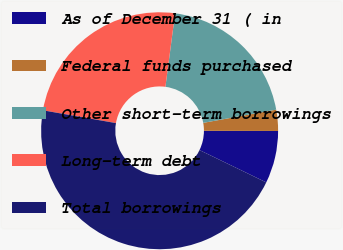Convert chart to OTSL. <chart><loc_0><loc_0><loc_500><loc_500><pie_chart><fcel>As of December 31 ( in<fcel>Federal funds purchased<fcel>Other short-term borrowings<fcel>Long-term debt<fcel>Total borrowings<nl><fcel>7.15%<fcel>2.88%<fcel>20.06%<fcel>24.33%<fcel>45.58%<nl></chart> 